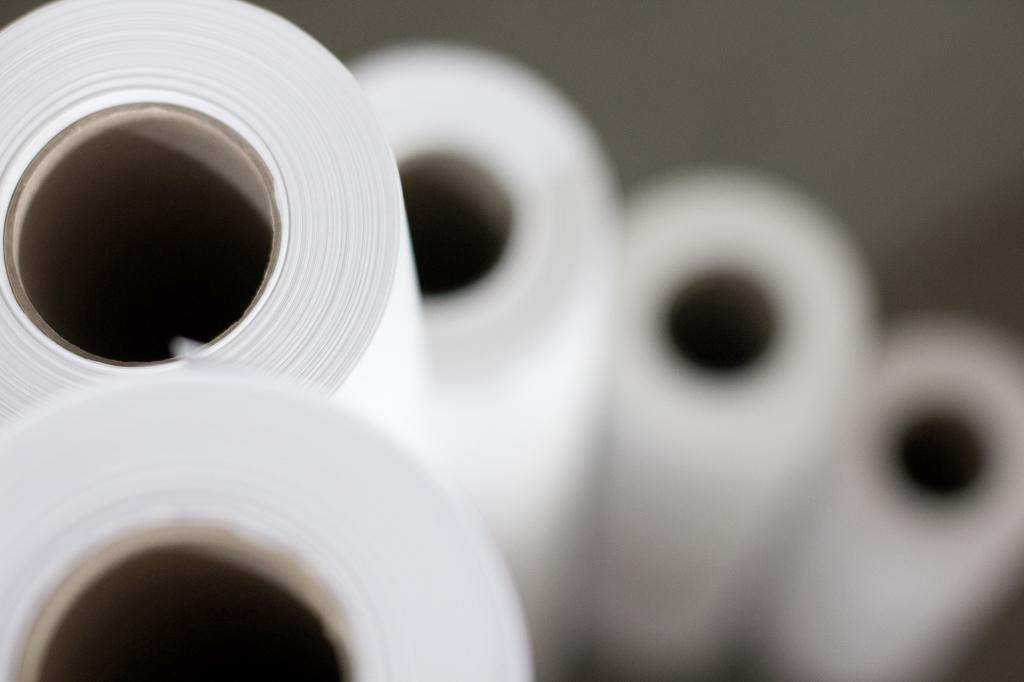Can you describe this image briefly? In this image I can see white color bundles. The background is blurred. 